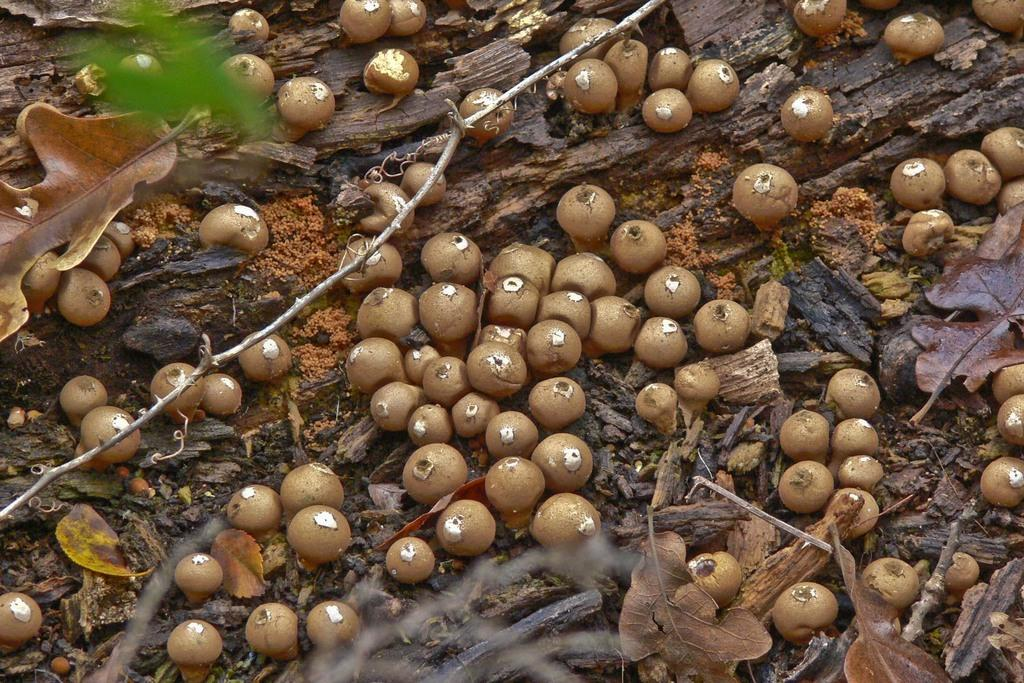What type of food can be seen in the image? There are fruits in the image. What else is present in the image besides the fruits? There are leaves in the image. What shape is the match in the image? There is no match present in the image. How many drops of water can be seen falling from the fruits in the image? There are no drops of water visible in the image; it only shows fruits and leaves. 